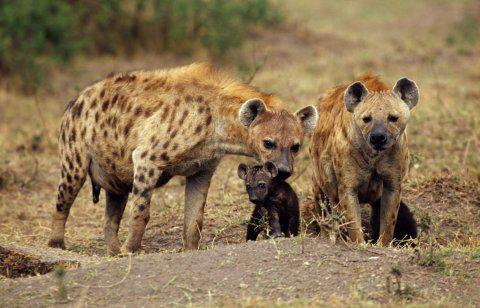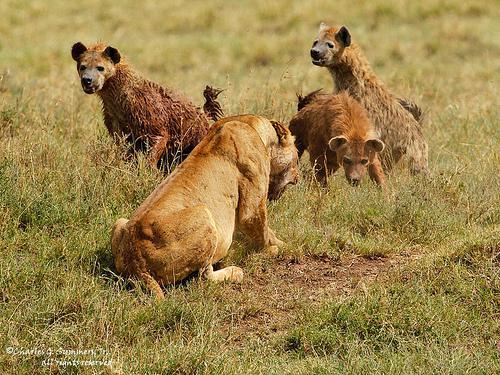The first image is the image on the left, the second image is the image on the right. Evaluate the accuracy of this statement regarding the images: "In the image to the left, at least one african_wild_dog faces off against a hyena.". Is it true? Answer yes or no. No. 